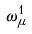Convert formula to latex. <formula><loc_0><loc_0><loc_500><loc_500>\omega _ { \mu } ^ { 1 }</formula> 